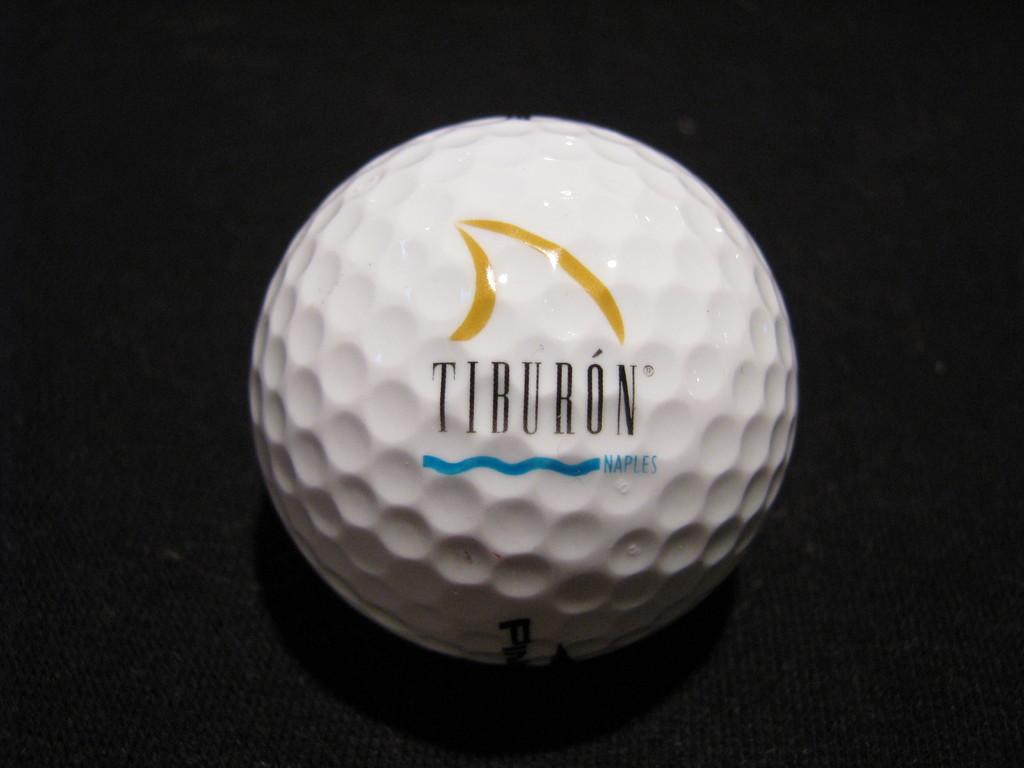What brand is printed on golf ball?
Provide a short and direct response. Tiburon. 